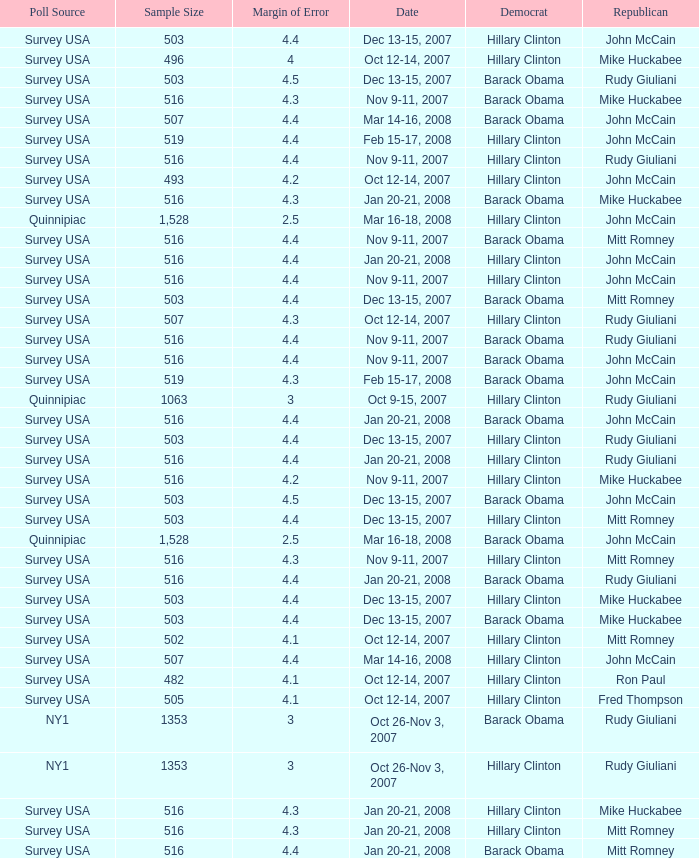What is the sample size of the poll taken on Dec 13-15, 2007 that had a margin of error of more than 4 and resulted with Republican Mike Huckabee? 503.0. 